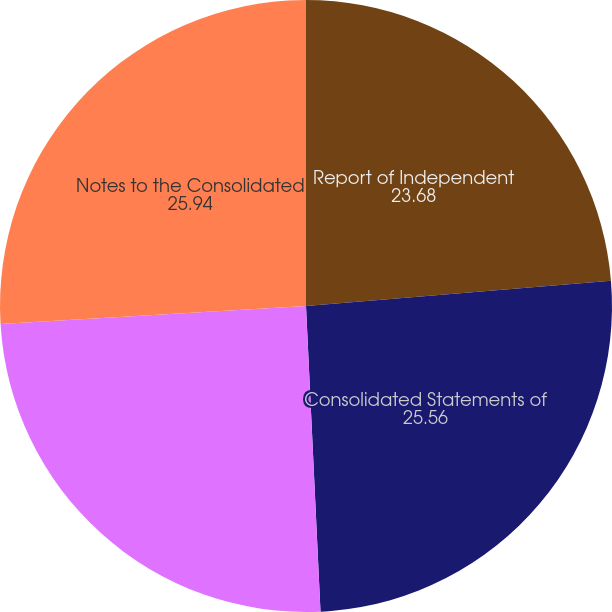Convert chart to OTSL. <chart><loc_0><loc_0><loc_500><loc_500><pie_chart><fcel>Report of Independent<fcel>Consolidated Statements of<fcel>Consolidated Balance Sheets<fcel>Notes to the Consolidated<nl><fcel>23.68%<fcel>25.56%<fcel>24.81%<fcel>25.94%<nl></chart> 